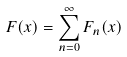<formula> <loc_0><loc_0><loc_500><loc_500>F ( x ) = \sum _ { n = 0 } ^ { \infty } F _ { n } ( x )</formula> 